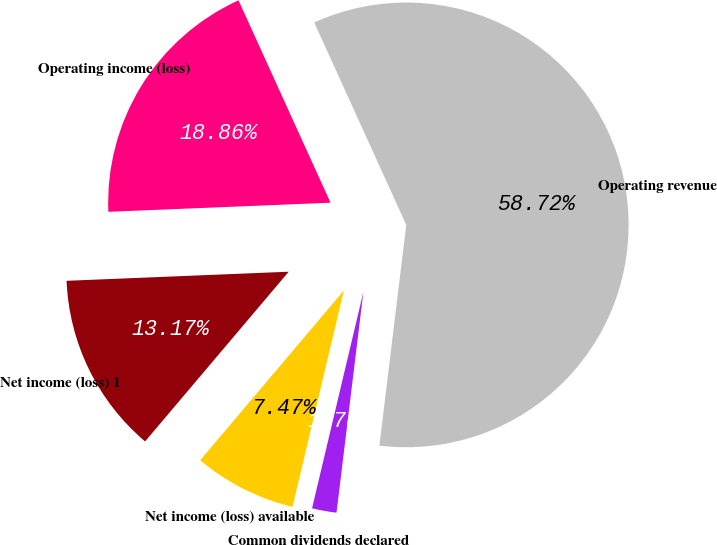Convert chart to OTSL. <chart><loc_0><loc_0><loc_500><loc_500><pie_chart><fcel>Operating revenue<fcel>Operating income (loss)<fcel>Net income (loss) 1<fcel>Net income (loss) available<fcel>Common dividends declared<nl><fcel>58.72%<fcel>18.86%<fcel>13.17%<fcel>7.47%<fcel>1.78%<nl></chart> 